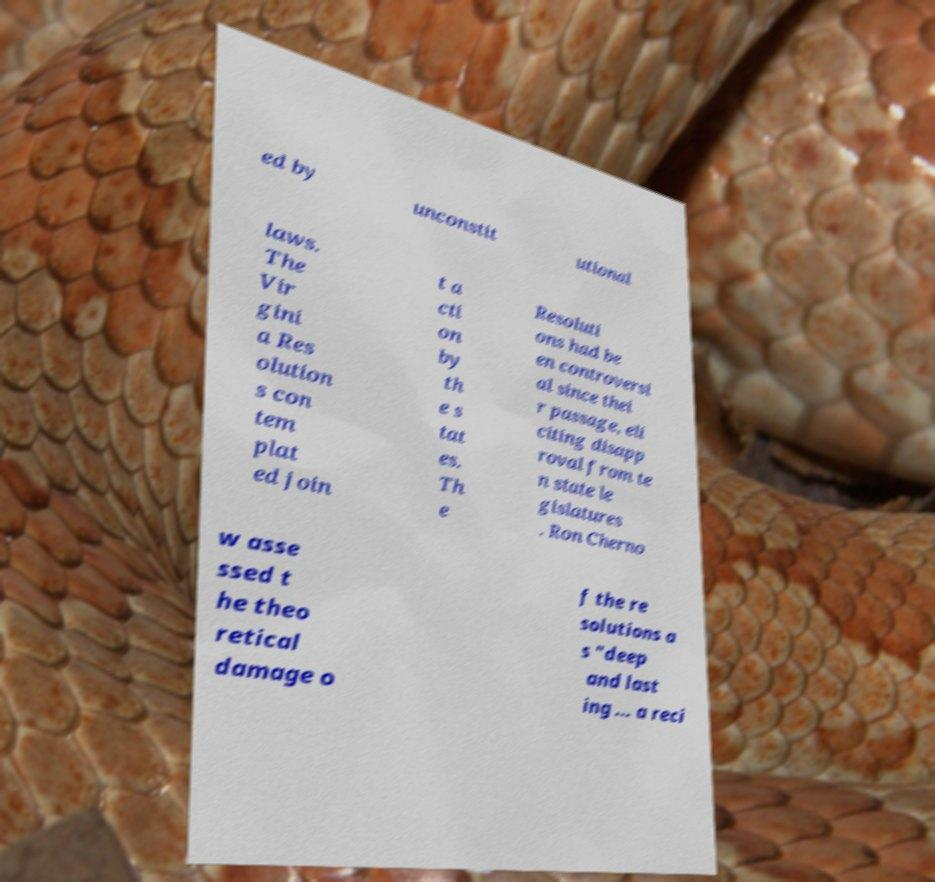Could you extract and type out the text from this image? ed by unconstit utional laws. The Vir gini a Res olution s con tem plat ed join t a cti on by th e s tat es. Th e Resoluti ons had be en controversi al since thei r passage, eli citing disapp roval from te n state le gislatures . Ron Cherno w asse ssed t he theo retical damage o f the re solutions a s "deep and last ing ... a reci 